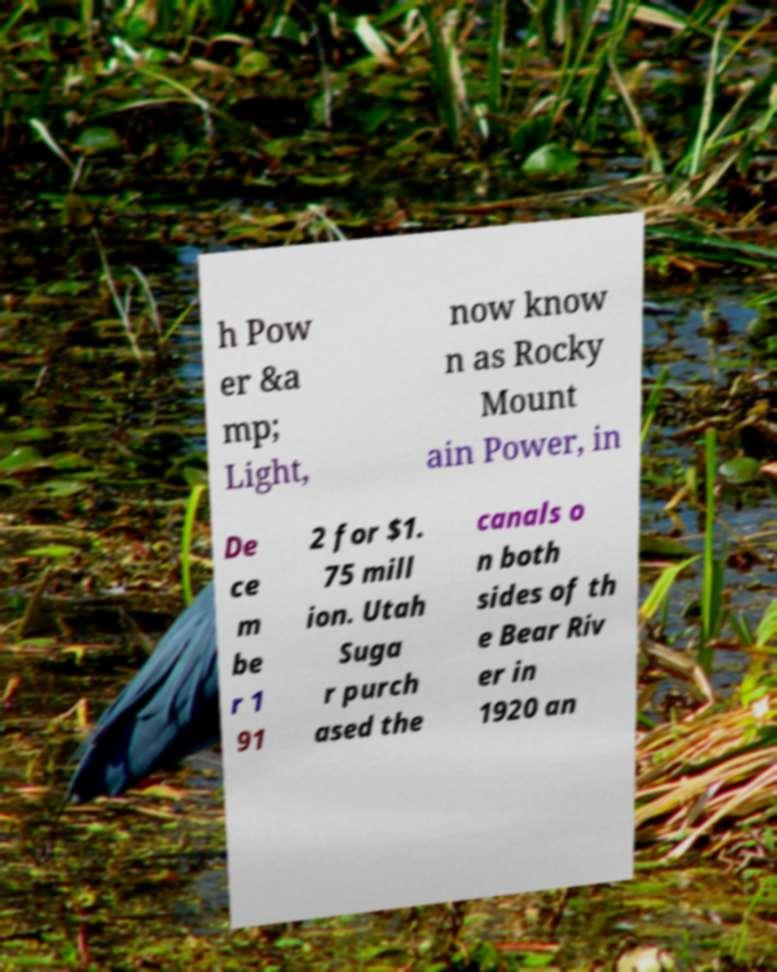Could you assist in decoding the text presented in this image and type it out clearly? h Pow er &a mp; Light, now know n as Rocky Mount ain Power, in De ce m be r 1 91 2 for $1. 75 mill ion. Utah Suga r purch ased the canals o n both sides of th e Bear Riv er in 1920 an 